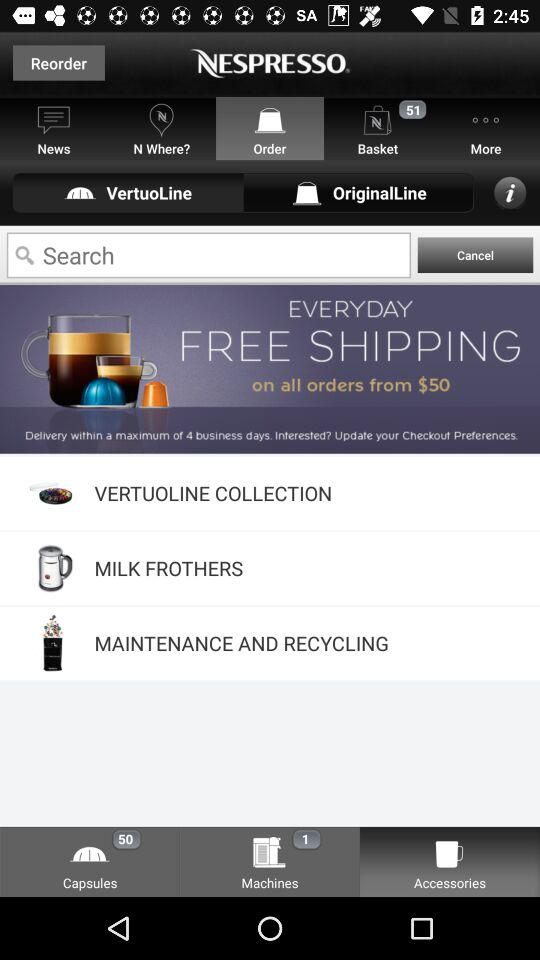What is the name of the application? The name of the application is "NESPRESSO". 